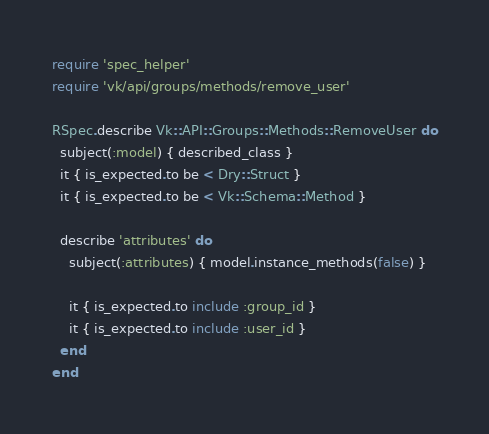<code> <loc_0><loc_0><loc_500><loc_500><_Ruby_>require 'spec_helper'
require 'vk/api/groups/methods/remove_user'

RSpec.describe Vk::API::Groups::Methods::RemoveUser do
  subject(:model) { described_class }
  it { is_expected.to be < Dry::Struct }
  it { is_expected.to be < Vk::Schema::Method }

  describe 'attributes' do
    subject(:attributes) { model.instance_methods(false) }

    it { is_expected.to include :group_id }
    it { is_expected.to include :user_id }
  end
end
</code> 